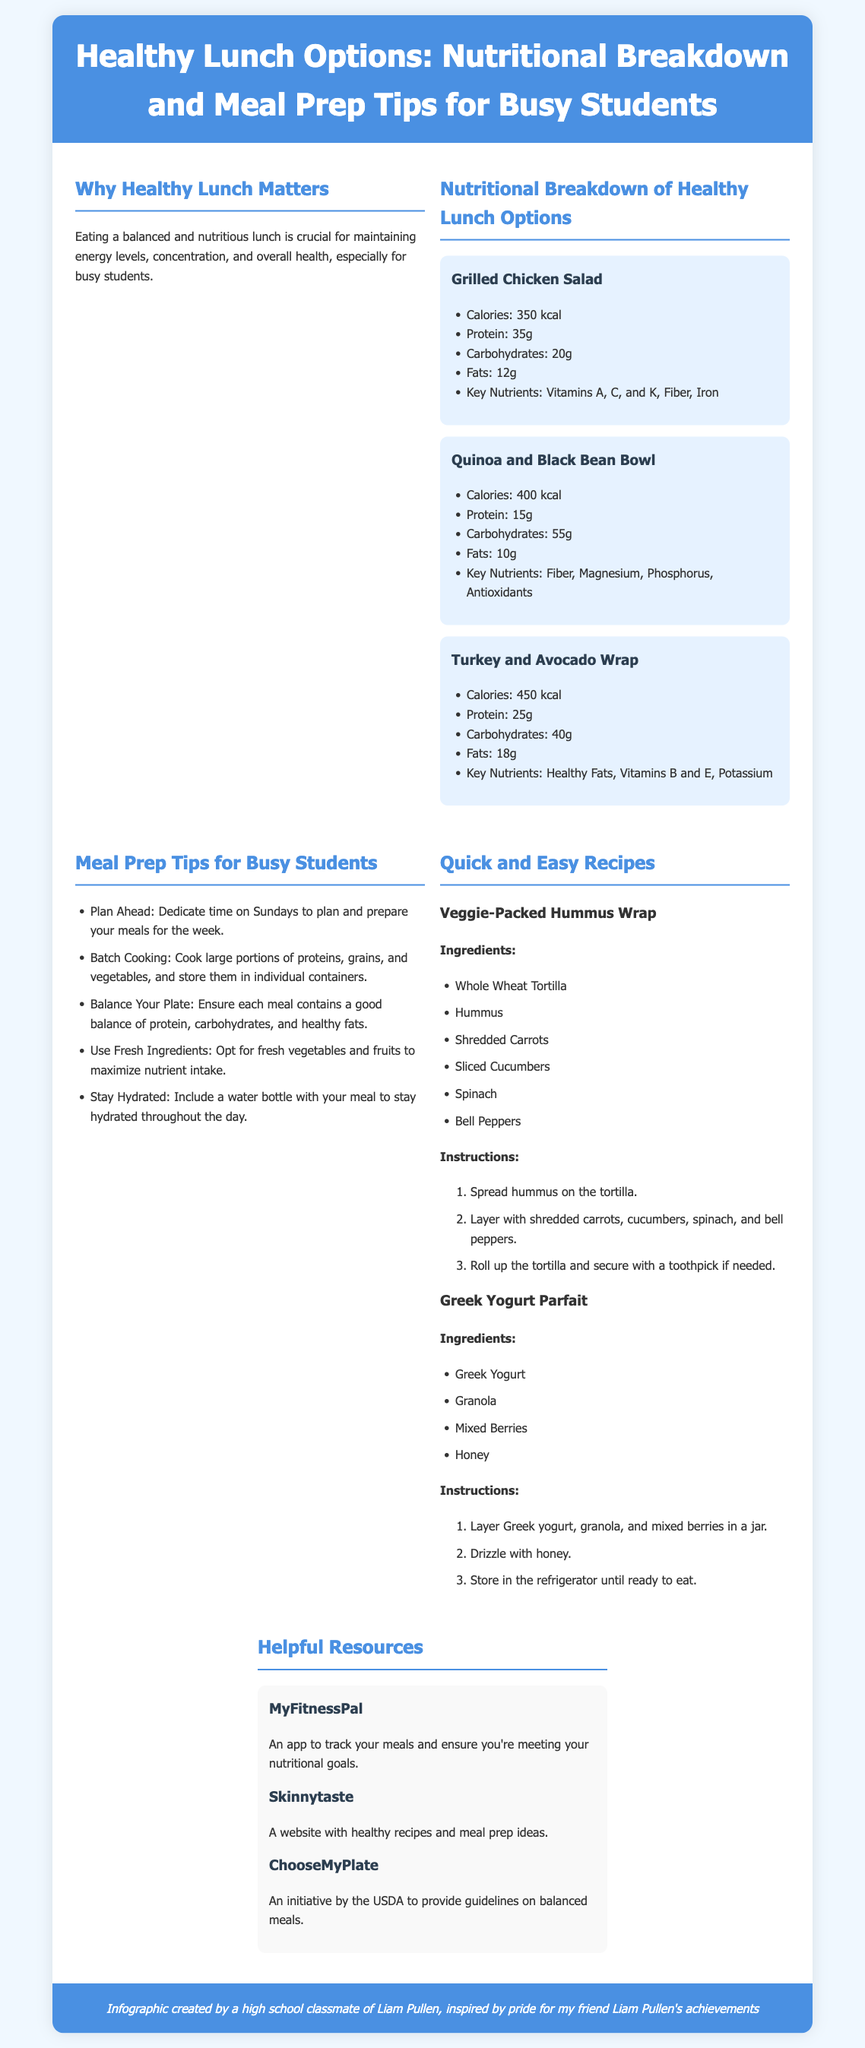What are the key nutrients in Grilled Chicken Salad? The key nutrients listed for Grilled Chicken Salad are Vitamins A, C, and K, Fiber, Iron.
Answer: Vitamins A, C, and K, Fiber, Iron How many calories does the Quinoa and Black Bean Bowl contain? The calorie content for Quinoa and Black Bean Bowl is specified in the document.
Answer: 400 kcal What is one tip for meal prep for busy students? The document provides multiple tips; one of them can be used as an answer.
Answer: Plan Ahead What type of yogurt is used in the Greek Yogurt Parfait? The ingredient list specifies the type of yogurt used in the recipe.
Answer: Greek Yogurt What is the protein content of the Turkey and Avocado Wrap? The document lists the protein content associated with the Turkey and Avocado Wrap.
Answer: 25g Which app is recommended for tracking meals? The document mentions specific apps for meal tracking.
Answer: MyFitnessPal How many grams of carbohydrates are in Grilled Chicken Salad? The nutritional breakdown indicates the carbohydrate amount in Grilled Chicken Salad.
Answer: 20g Name one website that offers healthy recipes. The document provides a list of helpful resources with various websites; one can be used.
Answer: Skinnytaste What should each meal contain according to the meal prep tips? The document states that meals should have a specific balance, which can be referenced.
Answer: Good balance of protein, carbohydrates, and healthy fats 